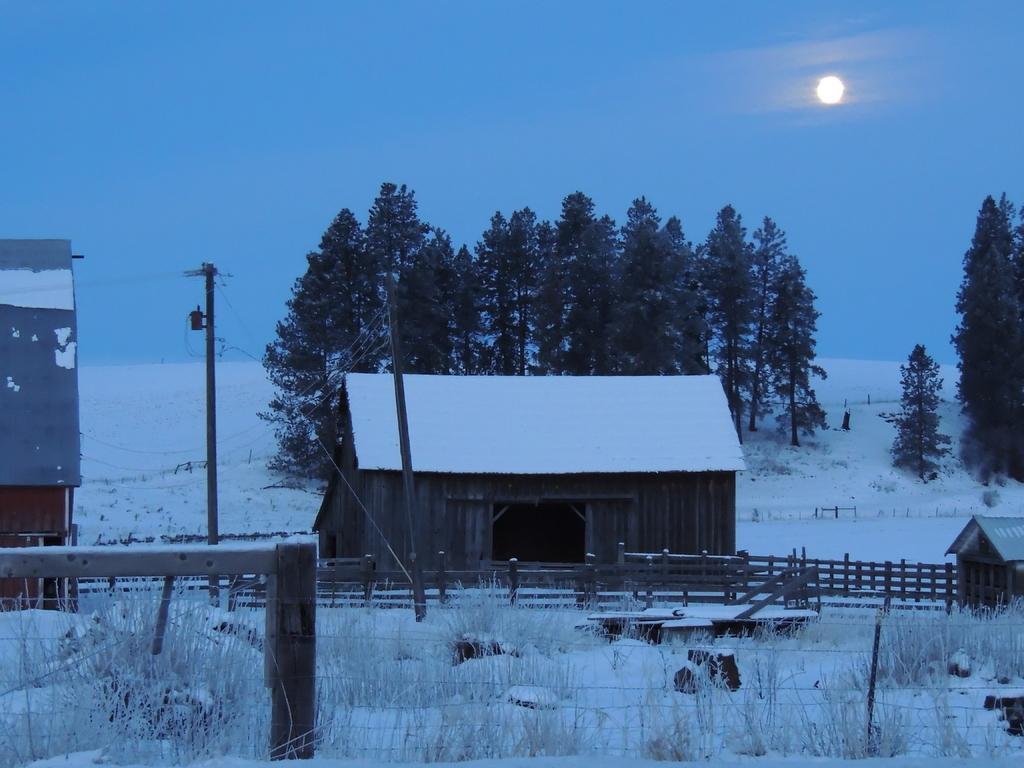Can you describe this image briefly? In the center of the image we can see a house which is covered with snow and also we can see a door. In the background of the image we can see the trees, houses, fence, plants, pole, wires and snow. At the top of the image we can see the sun in the sky. 